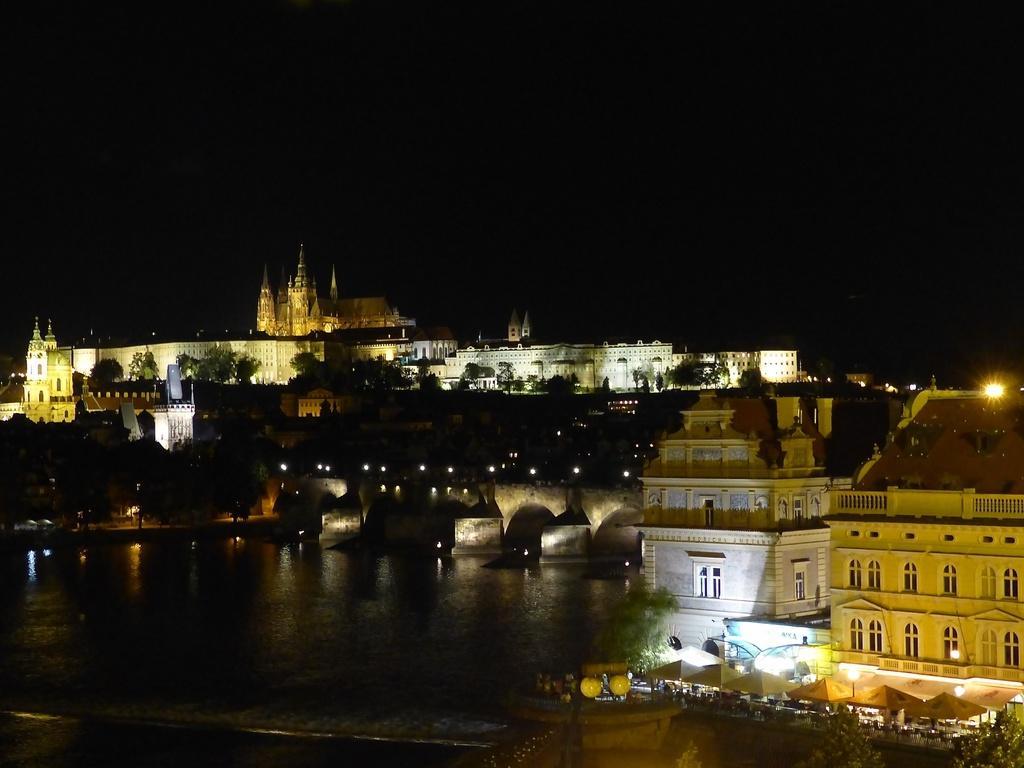Please provide a concise description of this image. This image is clicked outside. There are buildings in the middle. There is water at the bottom. There are trees in the middle. There is sky at the top. 